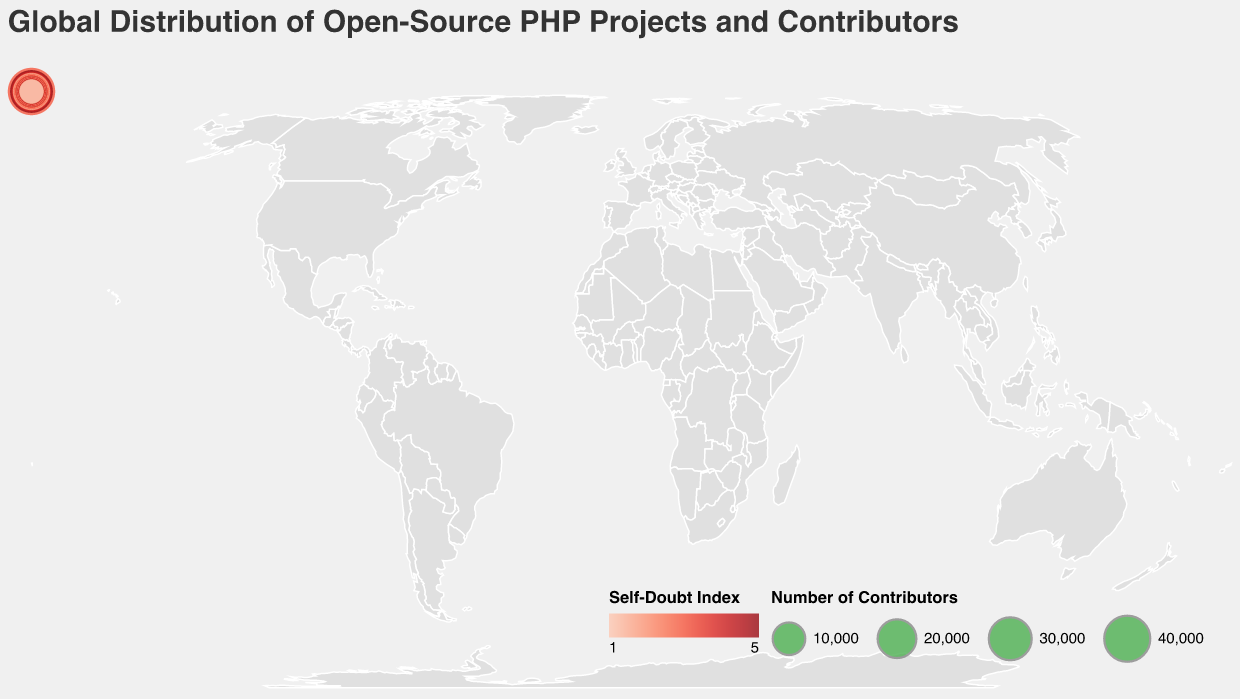What is the country with the highest number of PHP projects? Look at the bubble with the largest size on the map. From the tooltip or the size legend, identify the country. The United States has 12,500 PHP projects, the highest in the dataset.
Answer: United States What is the average Self-Doubt Index across all countries? Sum the Self-Doubt Index values for all countries and divide by the number of countries. Summing: 3 + 5 + 4 + 2 + 1 + 3 + 2 + 4 + 3 + 5 + 2 + 3 + 4 + 1 + 3 + 4 + 3 + 5 + 2 + 1 = 61. There are 20 countries, so the average is 61 / 20 = 3.05
Answer: 3.05 Which country in Europe has the highest number of Contributors? Identify the European countries on the map and compare their Contributor counts. Germany has 22,000 Contributors, the highest among European countries in the dataset.
Answer: Germany Compare the number of PHP projects between Brazil and Canada. Which one has more and by how much? Look at the PHP Projects values for Brazil (3,000) and Canada (3,500). Subtract Brazil's count from Canada's. 3,500 - 3,000 = 500. Thus, Canada has 500 more PHP projects than Brazil.
Answer: Canada, 500 What is the total number of Contributors in countries with a Self-Doubt Index of 4? Identify the countries with a Self-Doubt Index of 4: Germany, Brazil, Italy, Japan. Sum their Contributor counts: 22,000 (Germany) + 10,000 (Brazil) + 6,000 (Italy) + 4,500 (Japan) = 42,500.
Answer: 42,500 Which country has the smallest bubble size on the map? The size of the bubble corresponds to the number of Contributors. The country with the smallest bubble is Belgium with 3,000 Contributors.
Answer: Belgium What is the difference in the Self-Doubt Index between India and the Netherlands? Look at the Self-Doubt Index values for India (5) and the Netherlands (1). Subtract the Netherlands' index from India's index. 5 - 1 = 4.
Answer: 4 How many countries have a Self-Doubt Index less than 3? Count the number of countries with a Self-Doubt Index of 1 or 2. These countries are: Netherlands, United Kingdom, Canada, Australia, Sweden, Switzerland, Belgium. Total: 7 countries.
Answer: 7 What is the average number of PHP projects in the top 5 countries by Contributors? Identify the top 5 countries by Contributors: United States (45,000), India (30,000), Germany (22,000), United Kingdom (18,000), Netherlands (15,000). Find their PHP project counts: 12,500, 8,000, 6,500, 5,000, 4,500; Sum: 12,500 + 8,000 + 6,500 + 5,000 + 4,500 = 36,500. Average: 36,500 / 5 = 7,300.
Answer: 7,300 